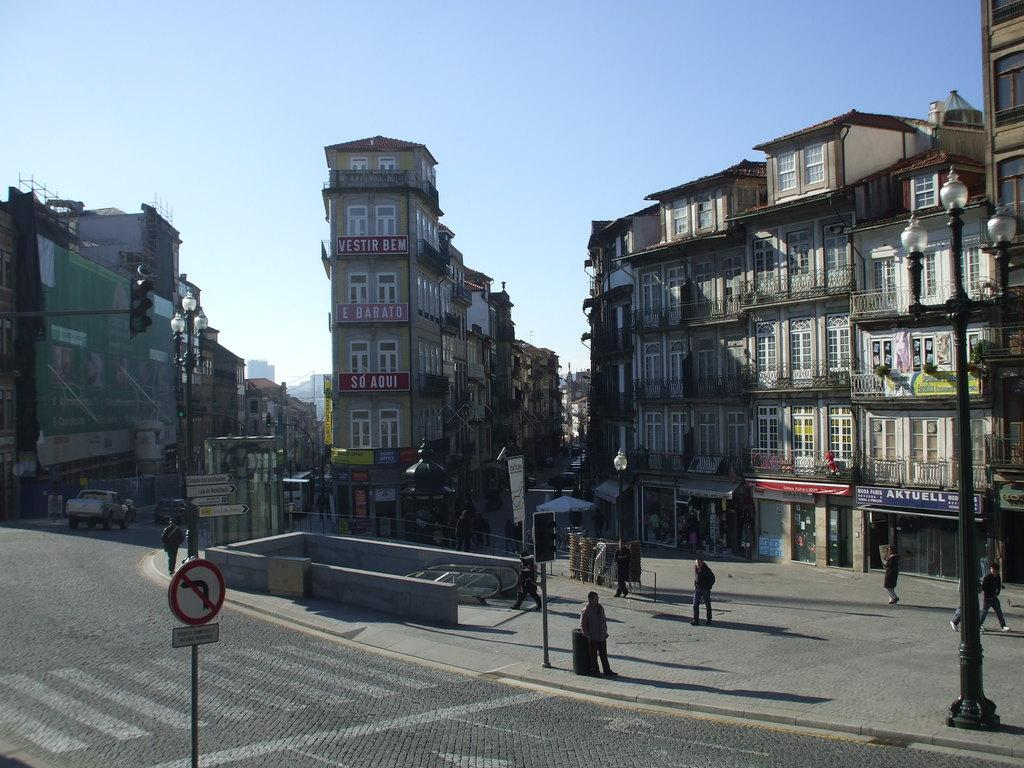What structures can be seen at the bottom of the image? There are poles and sign boards at the bottom of the image. What are the people in the image doing? There are people walking in the image. What else can be seen moving in the image? Vehicles are visible in the image. What type of man-made structures are present in the image? There are buildings in the image. What is visible at the top of the image? The sky is visible at the top of the image. Can you tell me about the history of the oven in the image? There is no oven present in the image. How many deer can be seen in the image? There are no deer present in the image. 